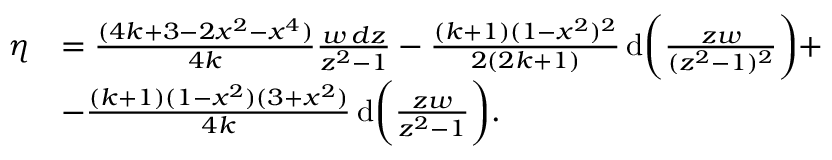Convert formula to latex. <formula><loc_0><loc_0><loc_500><loc_500>\begin{array} { r l } { \eta } & { = \frac { ( 4 k + 3 - 2 x ^ { 2 } - x ^ { 4 } ) } { 4 k } \frac { w \, d z } { z ^ { 2 } - 1 } - \frac { ( k + 1 ) ( 1 - x ^ { 2 } ) ^ { 2 } } { 2 ( 2 k + 1 ) } \, d \left ( \frac { z w } { ( z ^ { 2 } - 1 ) ^ { 2 } } \right ) + } \\ & { - \frac { ( k + 1 ) ( 1 - x ^ { 2 } ) ( 3 + x ^ { 2 } ) } { 4 k } \, d \left ( \frac { z w } { z ^ { 2 } - 1 } \right ) . } \end{array}</formula> 